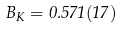Convert formula to latex. <formula><loc_0><loc_0><loc_500><loc_500>B _ { K } = 0 . 5 7 1 ( 1 7 )</formula> 